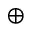Convert formula to latex. <formula><loc_0><loc_0><loc_500><loc_500>\oplus</formula> 